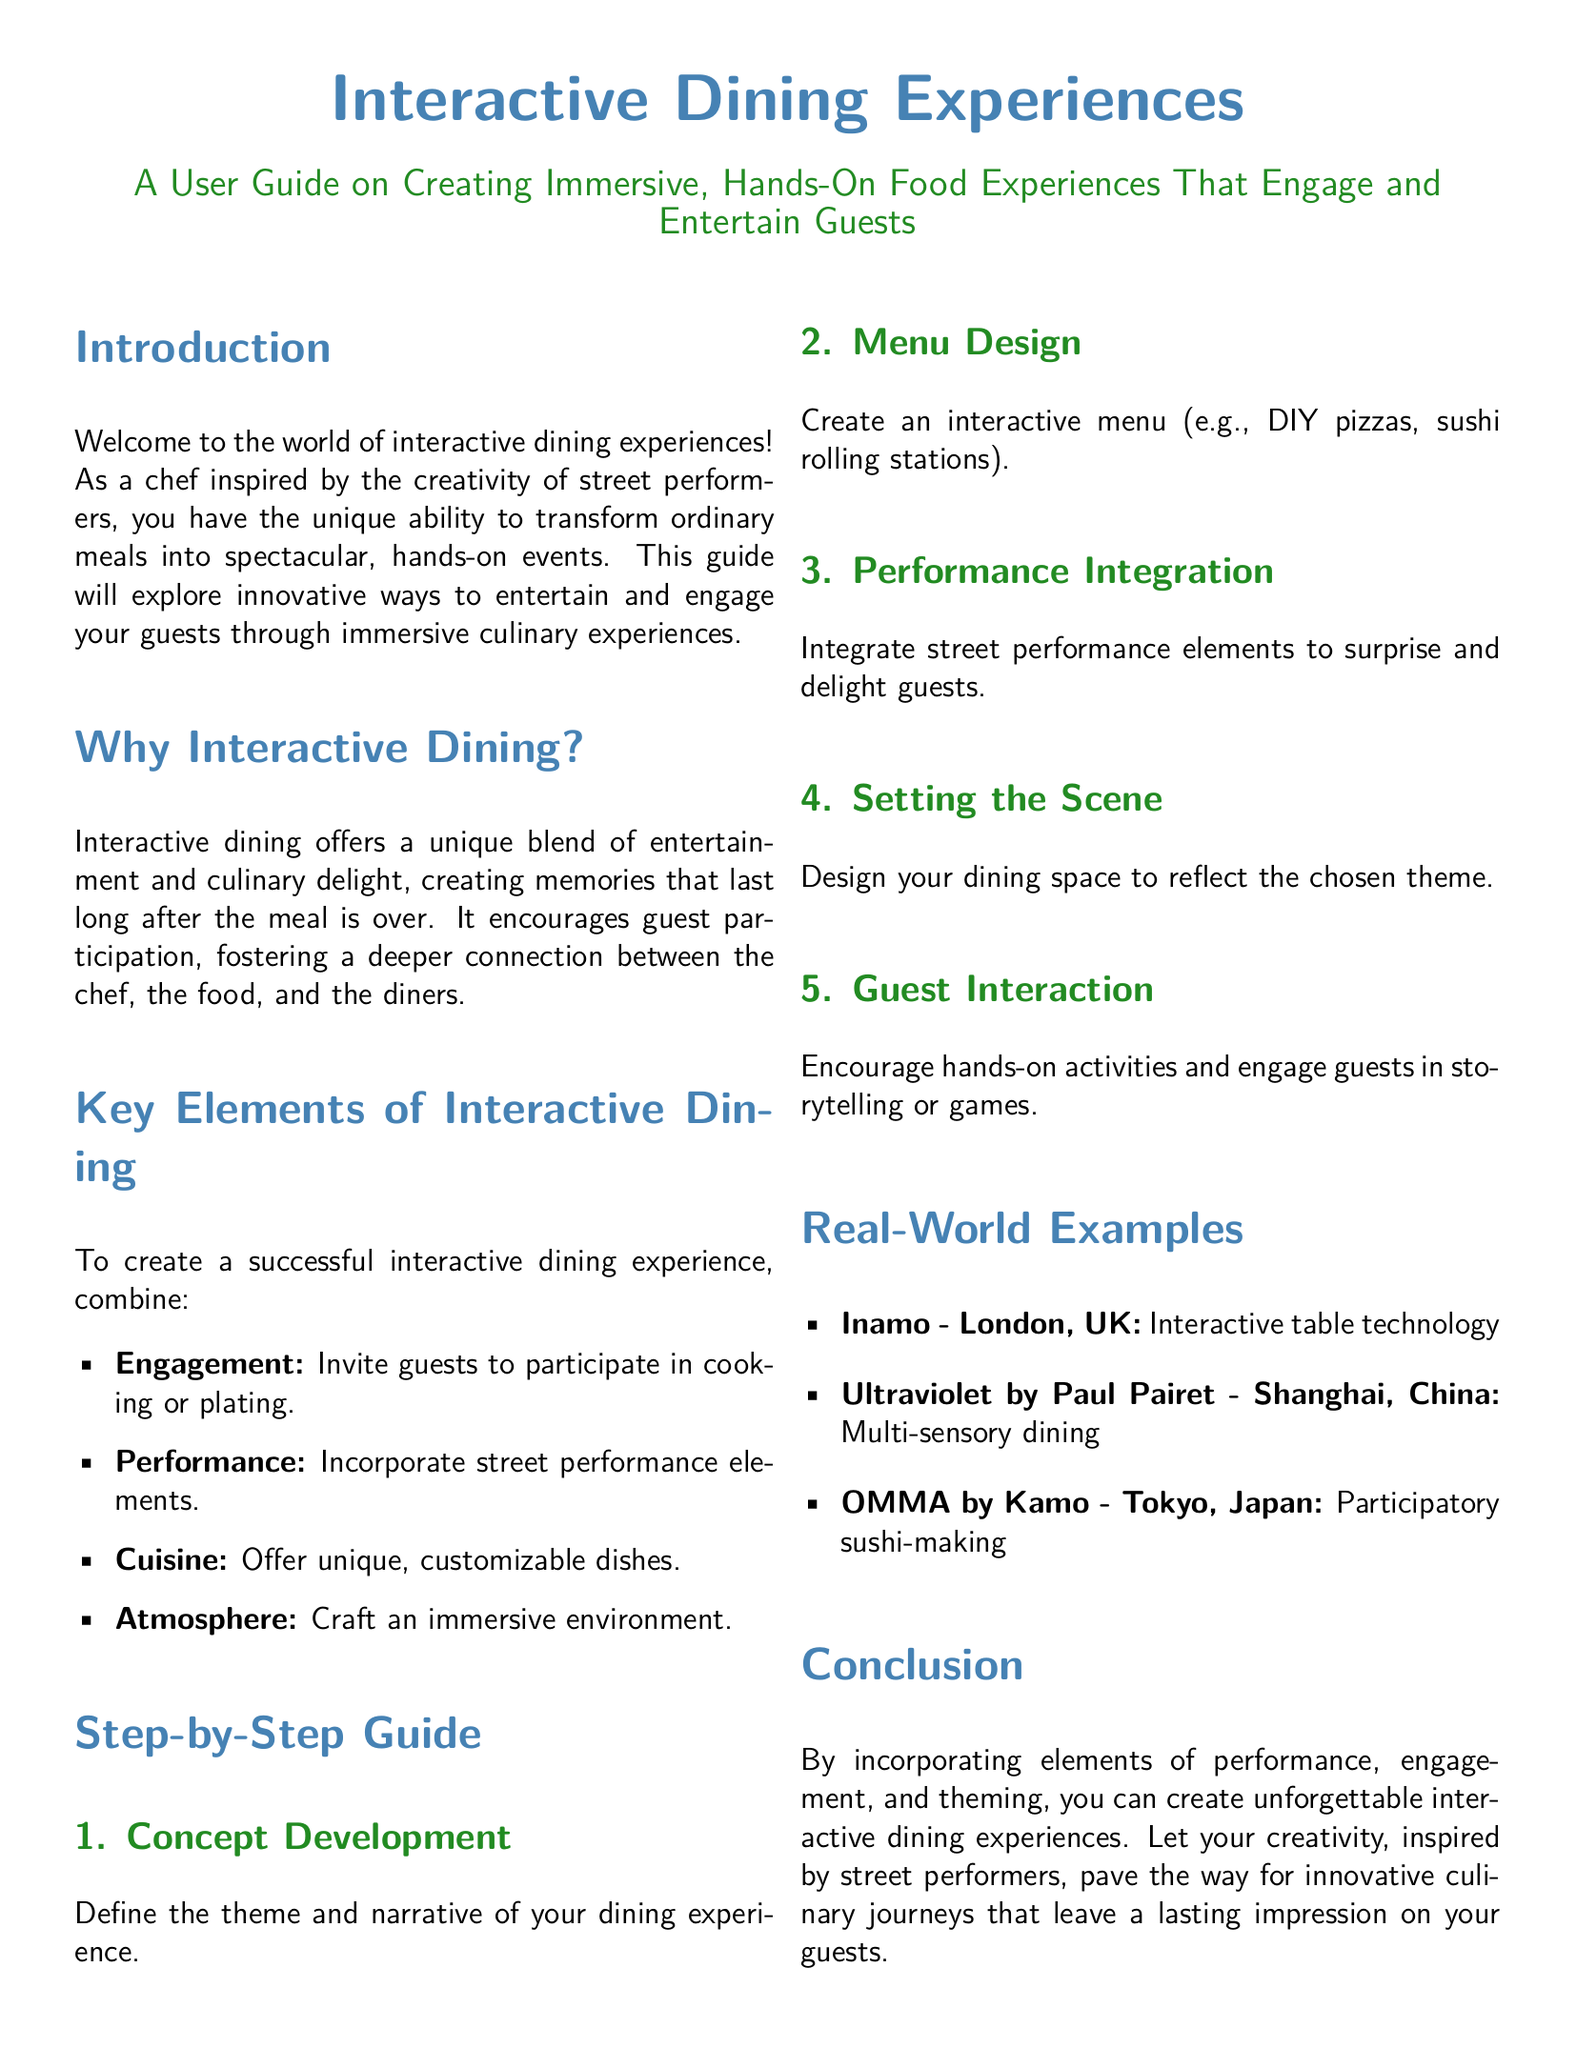what is the title of the user guide? The title of the user guide is presented prominently at the start of the document.
Answer: Interactive Dining Experiences what is the main focus of interactive dining experiences? The focus of interactive dining experiences is outlined in the introduction and emphasizes engagement and entertainment.
Answer: Engaging and entertaining guests how many key elements are mentioned for interactive dining? The document lists the key elements in a bullet point format, specifying their count.
Answer: Four what is one real-world example of interactive dining mentioned? The document provides examples of venues that exemplify interactive dining experiences.
Answer: Inamo - London, UK what is the first step in the step-by-step guide? The steps in the guide are numbered, with the first step being clearly stated.
Answer: Concept Development why is guest participation important in interactive dining? The reason for guest participation is explained in the context of its benefits to the dining experience.
Answer: Fosters deeper connection how does the user guide suggest integrating street performance? The guide includes a specific step that mentions integrating performance elements.
Answer: Performance Integration what color is used for section titles? The color coding for section titles is described in the document's formatting section.
Answer: Chefblue 